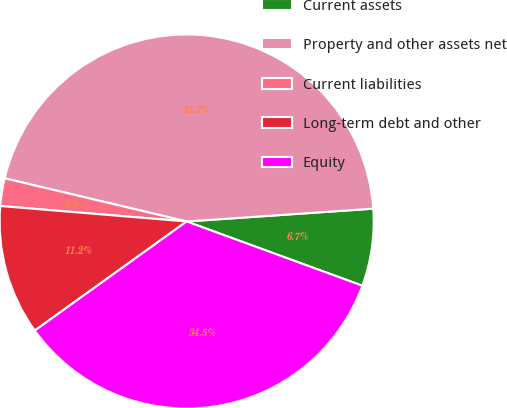Convert chart to OTSL. <chart><loc_0><loc_0><loc_500><loc_500><pie_chart><fcel>Current assets<fcel>Property and other assets net<fcel>Current liabilities<fcel>Long-term debt and other<fcel>Equity<nl><fcel>6.67%<fcel>45.2%<fcel>2.39%<fcel>11.23%<fcel>34.51%<nl></chart> 